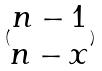<formula> <loc_0><loc_0><loc_500><loc_500>( \begin{matrix} n - 1 \\ n - x \end{matrix} )</formula> 